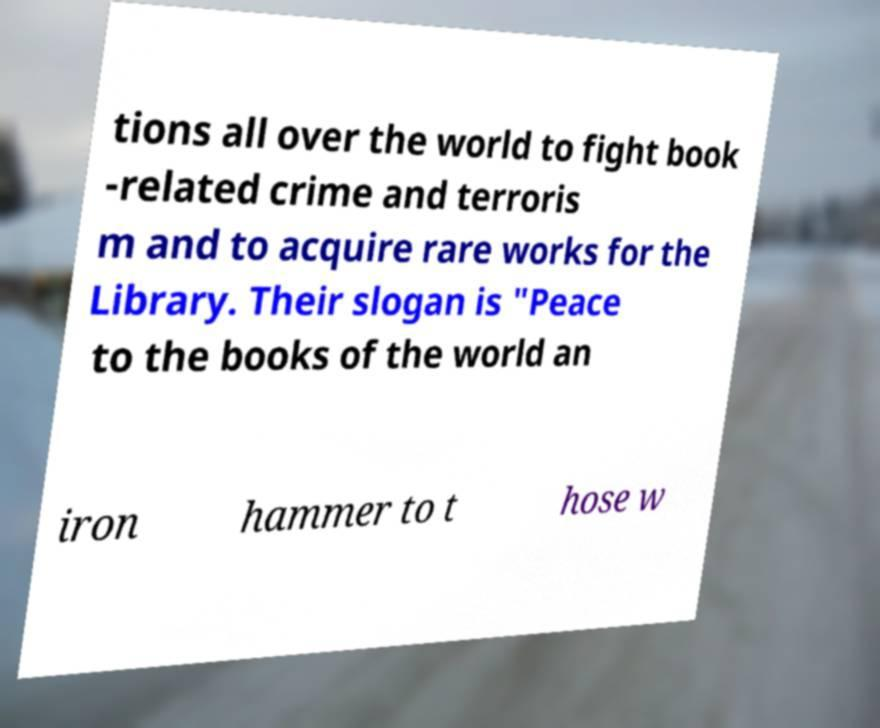Please read and relay the text visible in this image. What does it say? tions all over the world to fight book -related crime and terroris m and to acquire rare works for the Library. Their slogan is "Peace to the books of the world an iron hammer to t hose w 